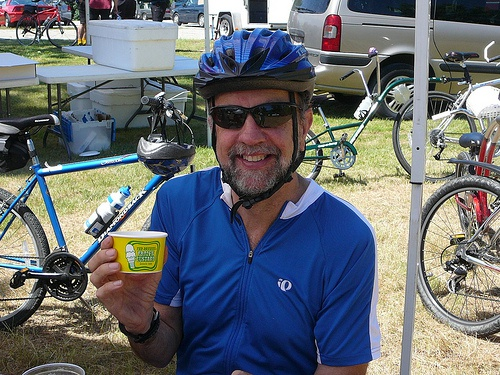Describe the objects in this image and their specific colors. I can see people in ivory, navy, black, darkblue, and blue tones, bicycle in ivory, black, khaki, and gray tones, bicycle in ivory, gray, black, white, and darkgray tones, car in ivory, gray, black, and darkgray tones, and bicycle in ivory, gray, darkgray, and beige tones in this image. 